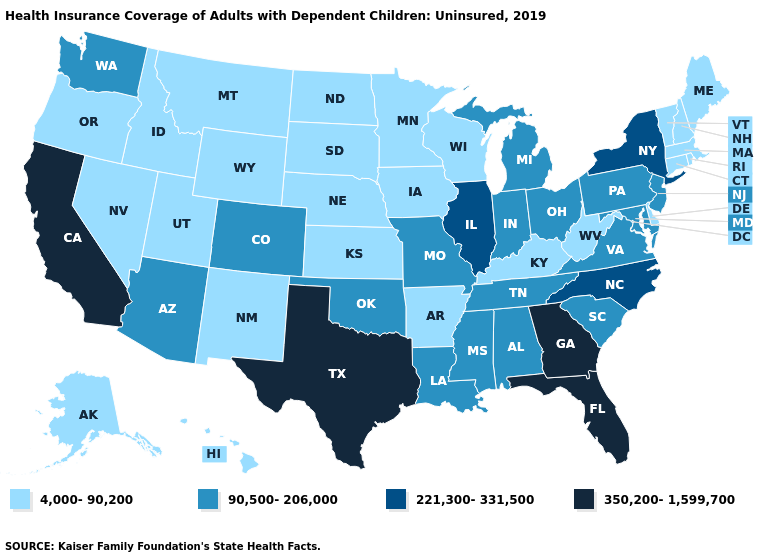Among the states that border North Dakota , which have the highest value?
Concise answer only. Minnesota, Montana, South Dakota. What is the value of Oregon?
Quick response, please. 4,000-90,200. Does Georgia have the highest value in the USA?
Write a very short answer. Yes. What is the lowest value in states that border Missouri?
Be succinct. 4,000-90,200. Which states have the lowest value in the West?
Concise answer only. Alaska, Hawaii, Idaho, Montana, Nevada, New Mexico, Oregon, Utah, Wyoming. Does the map have missing data?
Answer briefly. No. Does Oklahoma have the same value as Texas?
Quick response, please. No. What is the highest value in the USA?
Be succinct. 350,200-1,599,700. Name the states that have a value in the range 350,200-1,599,700?
Give a very brief answer. California, Florida, Georgia, Texas. Does Arizona have the lowest value in the USA?
Be succinct. No. What is the value of South Dakota?
Answer briefly. 4,000-90,200. Name the states that have a value in the range 350,200-1,599,700?
Write a very short answer. California, Florida, Georgia, Texas. Does the first symbol in the legend represent the smallest category?
Short answer required. Yes. Name the states that have a value in the range 350,200-1,599,700?
Write a very short answer. California, Florida, Georgia, Texas. Name the states that have a value in the range 350,200-1,599,700?
Give a very brief answer. California, Florida, Georgia, Texas. 